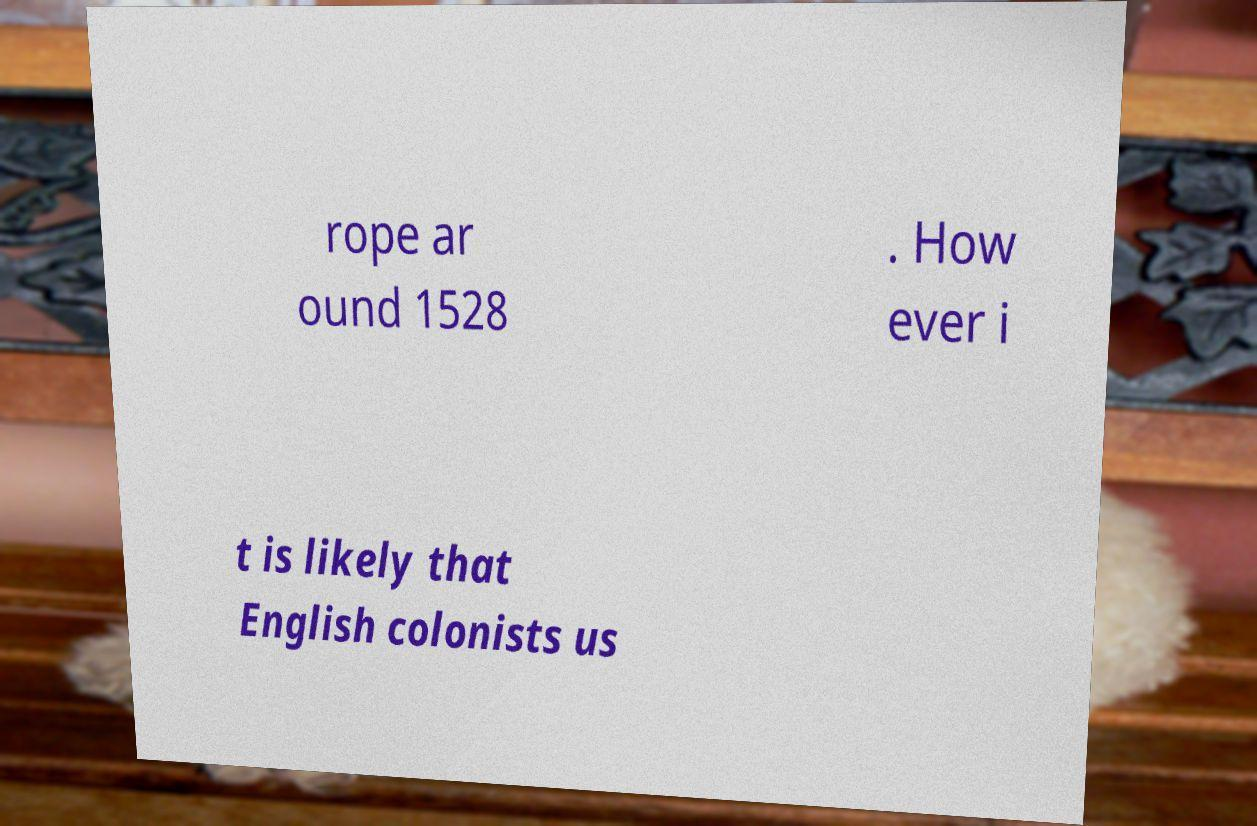For documentation purposes, I need the text within this image transcribed. Could you provide that? rope ar ound 1528 . How ever i t is likely that English colonists us 